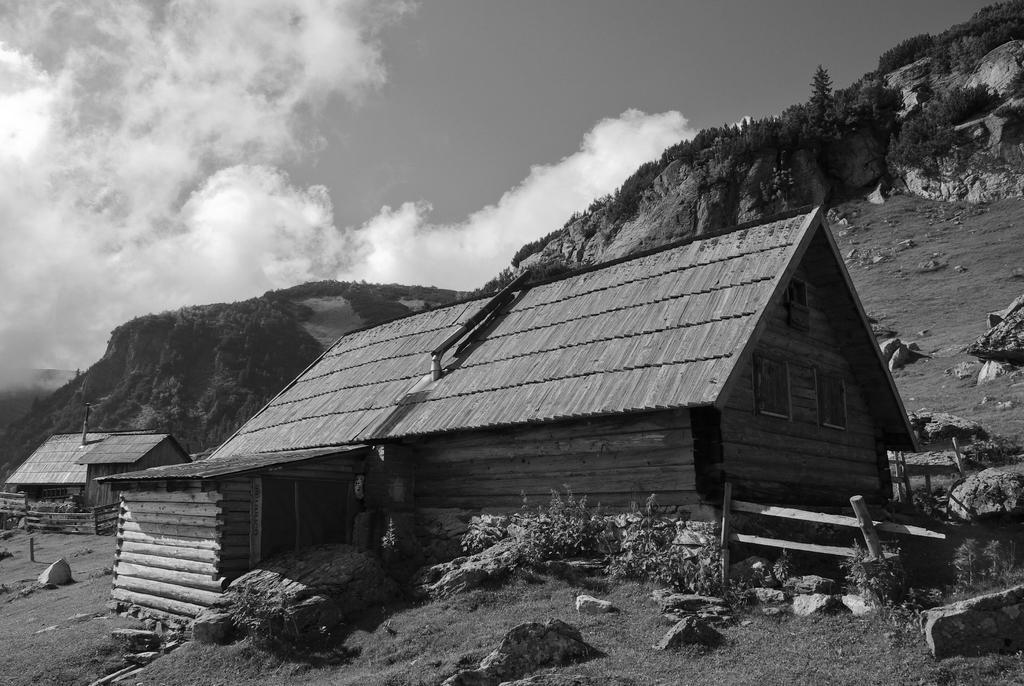Describe this image in one or two sentences. In this picture we can see sheds and plants and in the background we can see trees, rocks and the sky. 